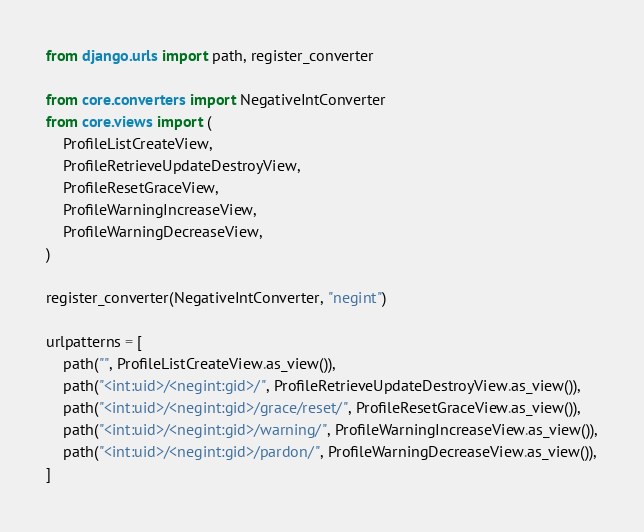Convert code to text. <code><loc_0><loc_0><loc_500><loc_500><_Python_>from django.urls import path, register_converter

from core.converters import NegativeIntConverter
from core.views import (
    ProfileListCreateView,
    ProfileRetrieveUpdateDestroyView,
    ProfileResetGraceView,
    ProfileWarningIncreaseView,
    ProfileWarningDecreaseView,
)

register_converter(NegativeIntConverter, "negint")

urlpatterns = [
    path("", ProfileListCreateView.as_view()),
    path("<int:uid>/<negint:gid>/", ProfileRetrieveUpdateDestroyView.as_view()),
    path("<int:uid>/<negint:gid>/grace/reset/", ProfileResetGraceView.as_view()),
    path("<int:uid>/<negint:gid>/warning/", ProfileWarningIncreaseView.as_view()),
    path("<int:uid>/<negint:gid>/pardon/", ProfileWarningDecreaseView.as_view()),
]
</code> 